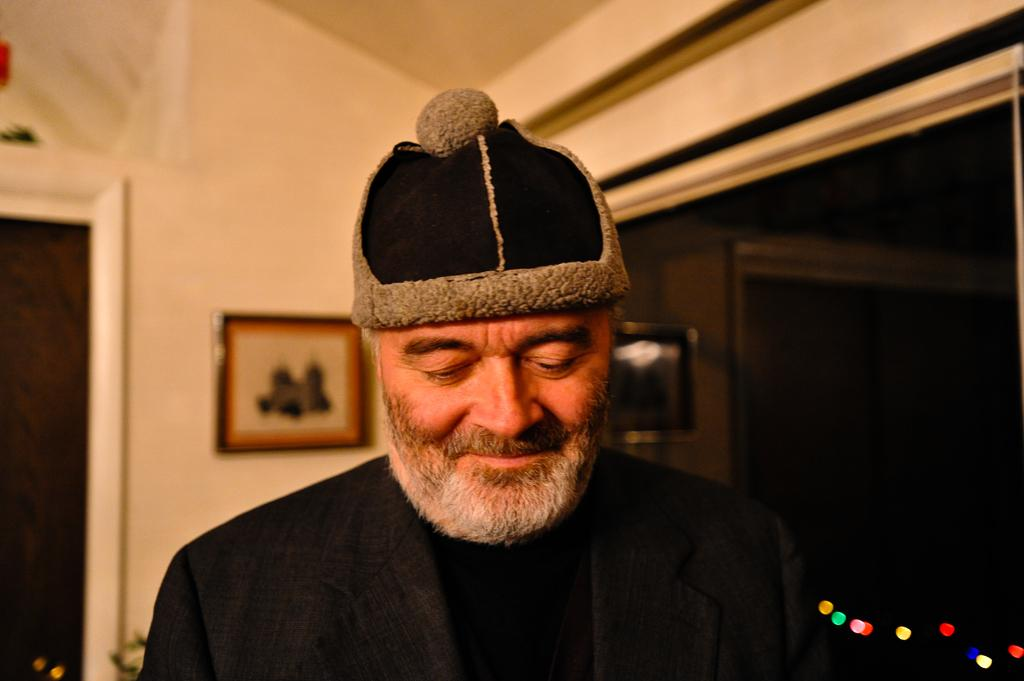What is the person in the image wearing on their head? The person in the image is wearing a cap. What can be seen in the background of the image? There is a glass, a frame attached to the wall, and a door in the background of the image. What type of bag is the person carrying in the image? There is no mention of a bag in the image. 